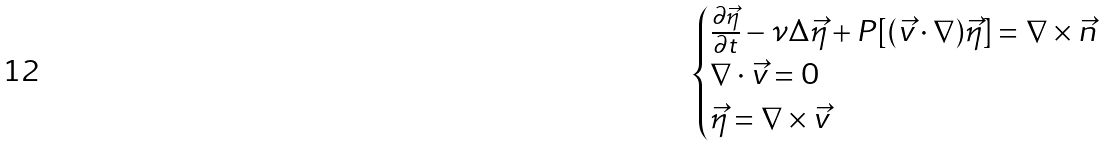Convert formula to latex. <formula><loc_0><loc_0><loc_500><loc_500>\begin{cases} \frac { \partial \vec { \eta } } { \partial t } - \nu \Delta \vec { \eta } + P [ ( \vec { v } \cdot \nabla ) \vec { \eta } ] = \nabla \times \vec { n } \\ \nabla \cdot \vec { v } = 0 \\ \vec { \eta } = \nabla \times \vec { v } \end{cases}</formula> 